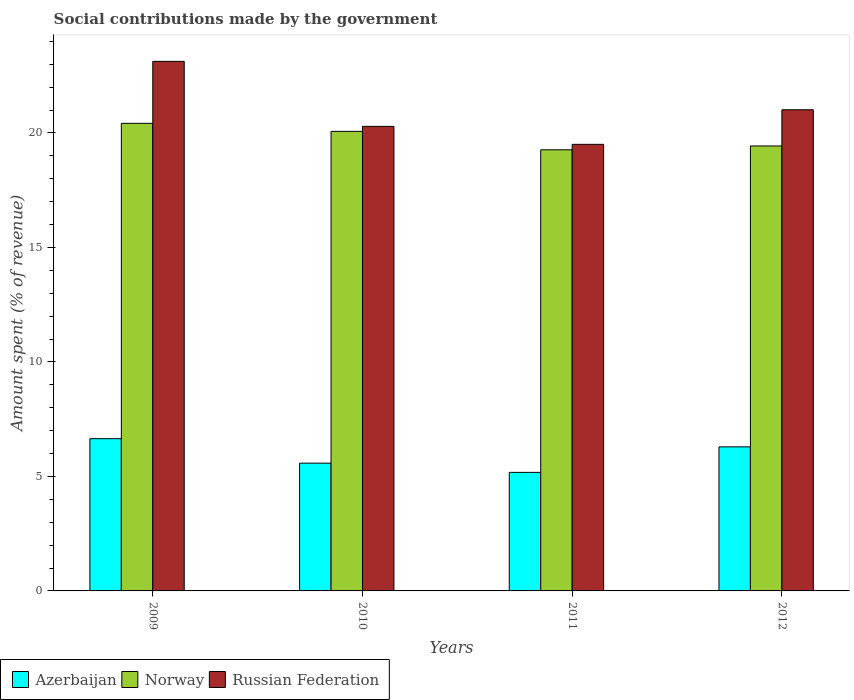How many different coloured bars are there?
Make the answer very short. 3. How many groups of bars are there?
Ensure brevity in your answer.  4. How many bars are there on the 2nd tick from the left?
Provide a succinct answer. 3. What is the label of the 1st group of bars from the left?
Offer a very short reply. 2009. What is the amount spent (in %) on social contributions in Russian Federation in 2012?
Your answer should be very brief. 21.01. Across all years, what is the maximum amount spent (in %) on social contributions in Norway?
Keep it short and to the point. 20.42. Across all years, what is the minimum amount spent (in %) on social contributions in Azerbaijan?
Provide a succinct answer. 5.18. In which year was the amount spent (in %) on social contributions in Azerbaijan maximum?
Ensure brevity in your answer.  2009. What is the total amount spent (in %) on social contributions in Azerbaijan in the graph?
Provide a short and direct response. 23.7. What is the difference between the amount spent (in %) on social contributions in Azerbaijan in 2010 and that in 2012?
Your answer should be very brief. -0.71. What is the difference between the amount spent (in %) on social contributions in Russian Federation in 2009 and the amount spent (in %) on social contributions in Norway in 2012?
Make the answer very short. 3.7. What is the average amount spent (in %) on social contributions in Norway per year?
Your response must be concise. 19.8. In the year 2009, what is the difference between the amount spent (in %) on social contributions in Azerbaijan and amount spent (in %) on social contributions in Norway?
Provide a succinct answer. -13.77. In how many years, is the amount spent (in %) on social contributions in Norway greater than 12 %?
Give a very brief answer. 4. What is the ratio of the amount spent (in %) on social contributions in Norway in 2010 to that in 2011?
Provide a succinct answer. 1.04. What is the difference between the highest and the second highest amount spent (in %) on social contributions in Azerbaijan?
Give a very brief answer. 0.36. What is the difference between the highest and the lowest amount spent (in %) on social contributions in Russian Federation?
Give a very brief answer. 3.62. What does the 3rd bar from the left in 2010 represents?
Your response must be concise. Russian Federation. How many bars are there?
Offer a terse response. 12. Are the values on the major ticks of Y-axis written in scientific E-notation?
Your response must be concise. No. Does the graph contain any zero values?
Ensure brevity in your answer.  No. How are the legend labels stacked?
Keep it short and to the point. Horizontal. What is the title of the graph?
Make the answer very short. Social contributions made by the government. What is the label or title of the Y-axis?
Provide a short and direct response. Amount spent (% of revenue). What is the Amount spent (% of revenue) in Azerbaijan in 2009?
Make the answer very short. 6.65. What is the Amount spent (% of revenue) in Norway in 2009?
Your answer should be compact. 20.42. What is the Amount spent (% of revenue) in Russian Federation in 2009?
Keep it short and to the point. 23.13. What is the Amount spent (% of revenue) of Azerbaijan in 2010?
Give a very brief answer. 5.58. What is the Amount spent (% of revenue) in Norway in 2010?
Your answer should be very brief. 20.07. What is the Amount spent (% of revenue) in Russian Federation in 2010?
Your response must be concise. 20.29. What is the Amount spent (% of revenue) in Azerbaijan in 2011?
Your response must be concise. 5.18. What is the Amount spent (% of revenue) in Norway in 2011?
Your response must be concise. 19.27. What is the Amount spent (% of revenue) of Russian Federation in 2011?
Provide a succinct answer. 19.5. What is the Amount spent (% of revenue) in Azerbaijan in 2012?
Offer a very short reply. 6.29. What is the Amount spent (% of revenue) of Norway in 2012?
Ensure brevity in your answer.  19.43. What is the Amount spent (% of revenue) of Russian Federation in 2012?
Your answer should be very brief. 21.01. Across all years, what is the maximum Amount spent (% of revenue) of Azerbaijan?
Provide a short and direct response. 6.65. Across all years, what is the maximum Amount spent (% of revenue) in Norway?
Keep it short and to the point. 20.42. Across all years, what is the maximum Amount spent (% of revenue) in Russian Federation?
Offer a very short reply. 23.13. Across all years, what is the minimum Amount spent (% of revenue) in Azerbaijan?
Your answer should be very brief. 5.18. Across all years, what is the minimum Amount spent (% of revenue) in Norway?
Keep it short and to the point. 19.27. Across all years, what is the minimum Amount spent (% of revenue) in Russian Federation?
Make the answer very short. 19.5. What is the total Amount spent (% of revenue) of Azerbaijan in the graph?
Offer a terse response. 23.7. What is the total Amount spent (% of revenue) in Norway in the graph?
Make the answer very short. 79.19. What is the total Amount spent (% of revenue) of Russian Federation in the graph?
Provide a short and direct response. 83.94. What is the difference between the Amount spent (% of revenue) of Azerbaijan in 2009 and that in 2010?
Your answer should be very brief. 1.07. What is the difference between the Amount spent (% of revenue) of Norway in 2009 and that in 2010?
Ensure brevity in your answer.  0.35. What is the difference between the Amount spent (% of revenue) of Russian Federation in 2009 and that in 2010?
Your response must be concise. 2.84. What is the difference between the Amount spent (% of revenue) in Azerbaijan in 2009 and that in 2011?
Your answer should be very brief. 1.47. What is the difference between the Amount spent (% of revenue) of Norway in 2009 and that in 2011?
Provide a succinct answer. 1.16. What is the difference between the Amount spent (% of revenue) in Russian Federation in 2009 and that in 2011?
Ensure brevity in your answer.  3.62. What is the difference between the Amount spent (% of revenue) in Azerbaijan in 2009 and that in 2012?
Provide a succinct answer. 0.36. What is the difference between the Amount spent (% of revenue) in Norway in 2009 and that in 2012?
Give a very brief answer. 0.99. What is the difference between the Amount spent (% of revenue) of Russian Federation in 2009 and that in 2012?
Offer a terse response. 2.11. What is the difference between the Amount spent (% of revenue) in Azerbaijan in 2010 and that in 2011?
Provide a short and direct response. 0.4. What is the difference between the Amount spent (% of revenue) of Norway in 2010 and that in 2011?
Your answer should be compact. 0.81. What is the difference between the Amount spent (% of revenue) of Russian Federation in 2010 and that in 2011?
Give a very brief answer. 0.78. What is the difference between the Amount spent (% of revenue) in Azerbaijan in 2010 and that in 2012?
Your response must be concise. -0.71. What is the difference between the Amount spent (% of revenue) of Norway in 2010 and that in 2012?
Keep it short and to the point. 0.64. What is the difference between the Amount spent (% of revenue) of Russian Federation in 2010 and that in 2012?
Your answer should be compact. -0.73. What is the difference between the Amount spent (% of revenue) in Azerbaijan in 2011 and that in 2012?
Provide a succinct answer. -1.11. What is the difference between the Amount spent (% of revenue) in Norway in 2011 and that in 2012?
Give a very brief answer. -0.17. What is the difference between the Amount spent (% of revenue) of Russian Federation in 2011 and that in 2012?
Make the answer very short. -1.51. What is the difference between the Amount spent (% of revenue) in Azerbaijan in 2009 and the Amount spent (% of revenue) in Norway in 2010?
Offer a terse response. -13.42. What is the difference between the Amount spent (% of revenue) of Azerbaijan in 2009 and the Amount spent (% of revenue) of Russian Federation in 2010?
Give a very brief answer. -13.64. What is the difference between the Amount spent (% of revenue) in Norway in 2009 and the Amount spent (% of revenue) in Russian Federation in 2010?
Your answer should be compact. 0.13. What is the difference between the Amount spent (% of revenue) of Azerbaijan in 2009 and the Amount spent (% of revenue) of Norway in 2011?
Your response must be concise. -12.62. What is the difference between the Amount spent (% of revenue) of Azerbaijan in 2009 and the Amount spent (% of revenue) of Russian Federation in 2011?
Your response must be concise. -12.86. What is the difference between the Amount spent (% of revenue) of Norway in 2009 and the Amount spent (% of revenue) of Russian Federation in 2011?
Ensure brevity in your answer.  0.92. What is the difference between the Amount spent (% of revenue) of Azerbaijan in 2009 and the Amount spent (% of revenue) of Norway in 2012?
Offer a terse response. -12.78. What is the difference between the Amount spent (% of revenue) in Azerbaijan in 2009 and the Amount spent (% of revenue) in Russian Federation in 2012?
Offer a terse response. -14.37. What is the difference between the Amount spent (% of revenue) in Norway in 2009 and the Amount spent (% of revenue) in Russian Federation in 2012?
Provide a succinct answer. -0.59. What is the difference between the Amount spent (% of revenue) in Azerbaijan in 2010 and the Amount spent (% of revenue) in Norway in 2011?
Offer a very short reply. -13.69. What is the difference between the Amount spent (% of revenue) in Azerbaijan in 2010 and the Amount spent (% of revenue) in Russian Federation in 2011?
Offer a terse response. -13.92. What is the difference between the Amount spent (% of revenue) in Norway in 2010 and the Amount spent (% of revenue) in Russian Federation in 2011?
Your response must be concise. 0.57. What is the difference between the Amount spent (% of revenue) in Azerbaijan in 2010 and the Amount spent (% of revenue) in Norway in 2012?
Provide a succinct answer. -13.85. What is the difference between the Amount spent (% of revenue) in Azerbaijan in 2010 and the Amount spent (% of revenue) in Russian Federation in 2012?
Provide a succinct answer. -15.43. What is the difference between the Amount spent (% of revenue) in Norway in 2010 and the Amount spent (% of revenue) in Russian Federation in 2012?
Provide a succinct answer. -0.94. What is the difference between the Amount spent (% of revenue) of Azerbaijan in 2011 and the Amount spent (% of revenue) of Norway in 2012?
Offer a terse response. -14.25. What is the difference between the Amount spent (% of revenue) of Azerbaijan in 2011 and the Amount spent (% of revenue) of Russian Federation in 2012?
Offer a very short reply. -15.84. What is the difference between the Amount spent (% of revenue) of Norway in 2011 and the Amount spent (% of revenue) of Russian Federation in 2012?
Your response must be concise. -1.75. What is the average Amount spent (% of revenue) in Azerbaijan per year?
Offer a terse response. 5.92. What is the average Amount spent (% of revenue) of Norway per year?
Your answer should be very brief. 19.8. What is the average Amount spent (% of revenue) of Russian Federation per year?
Give a very brief answer. 20.98. In the year 2009, what is the difference between the Amount spent (% of revenue) of Azerbaijan and Amount spent (% of revenue) of Norway?
Ensure brevity in your answer.  -13.77. In the year 2009, what is the difference between the Amount spent (% of revenue) in Azerbaijan and Amount spent (% of revenue) in Russian Federation?
Your answer should be compact. -16.48. In the year 2009, what is the difference between the Amount spent (% of revenue) of Norway and Amount spent (% of revenue) of Russian Federation?
Offer a terse response. -2.71. In the year 2010, what is the difference between the Amount spent (% of revenue) of Azerbaijan and Amount spent (% of revenue) of Norway?
Your response must be concise. -14.49. In the year 2010, what is the difference between the Amount spent (% of revenue) of Azerbaijan and Amount spent (% of revenue) of Russian Federation?
Your response must be concise. -14.71. In the year 2010, what is the difference between the Amount spent (% of revenue) in Norway and Amount spent (% of revenue) in Russian Federation?
Provide a succinct answer. -0.22. In the year 2011, what is the difference between the Amount spent (% of revenue) in Azerbaijan and Amount spent (% of revenue) in Norway?
Offer a terse response. -14.09. In the year 2011, what is the difference between the Amount spent (% of revenue) of Azerbaijan and Amount spent (% of revenue) of Russian Federation?
Your answer should be compact. -14.33. In the year 2011, what is the difference between the Amount spent (% of revenue) of Norway and Amount spent (% of revenue) of Russian Federation?
Keep it short and to the point. -0.24. In the year 2012, what is the difference between the Amount spent (% of revenue) in Azerbaijan and Amount spent (% of revenue) in Norway?
Provide a succinct answer. -13.14. In the year 2012, what is the difference between the Amount spent (% of revenue) of Azerbaijan and Amount spent (% of revenue) of Russian Federation?
Your answer should be compact. -14.72. In the year 2012, what is the difference between the Amount spent (% of revenue) in Norway and Amount spent (% of revenue) in Russian Federation?
Provide a succinct answer. -1.58. What is the ratio of the Amount spent (% of revenue) in Azerbaijan in 2009 to that in 2010?
Your answer should be compact. 1.19. What is the ratio of the Amount spent (% of revenue) of Norway in 2009 to that in 2010?
Offer a terse response. 1.02. What is the ratio of the Amount spent (% of revenue) of Russian Federation in 2009 to that in 2010?
Offer a terse response. 1.14. What is the ratio of the Amount spent (% of revenue) of Azerbaijan in 2009 to that in 2011?
Give a very brief answer. 1.28. What is the ratio of the Amount spent (% of revenue) of Norway in 2009 to that in 2011?
Provide a short and direct response. 1.06. What is the ratio of the Amount spent (% of revenue) in Russian Federation in 2009 to that in 2011?
Offer a very short reply. 1.19. What is the ratio of the Amount spent (% of revenue) in Azerbaijan in 2009 to that in 2012?
Offer a very short reply. 1.06. What is the ratio of the Amount spent (% of revenue) of Norway in 2009 to that in 2012?
Your answer should be very brief. 1.05. What is the ratio of the Amount spent (% of revenue) in Russian Federation in 2009 to that in 2012?
Make the answer very short. 1.1. What is the ratio of the Amount spent (% of revenue) in Azerbaijan in 2010 to that in 2011?
Offer a terse response. 1.08. What is the ratio of the Amount spent (% of revenue) in Norway in 2010 to that in 2011?
Keep it short and to the point. 1.04. What is the ratio of the Amount spent (% of revenue) in Russian Federation in 2010 to that in 2011?
Offer a very short reply. 1.04. What is the ratio of the Amount spent (% of revenue) in Azerbaijan in 2010 to that in 2012?
Ensure brevity in your answer.  0.89. What is the ratio of the Amount spent (% of revenue) of Norway in 2010 to that in 2012?
Provide a succinct answer. 1.03. What is the ratio of the Amount spent (% of revenue) of Russian Federation in 2010 to that in 2012?
Ensure brevity in your answer.  0.97. What is the ratio of the Amount spent (% of revenue) of Azerbaijan in 2011 to that in 2012?
Ensure brevity in your answer.  0.82. What is the ratio of the Amount spent (% of revenue) of Norway in 2011 to that in 2012?
Offer a terse response. 0.99. What is the ratio of the Amount spent (% of revenue) in Russian Federation in 2011 to that in 2012?
Your answer should be very brief. 0.93. What is the difference between the highest and the second highest Amount spent (% of revenue) in Azerbaijan?
Your response must be concise. 0.36. What is the difference between the highest and the second highest Amount spent (% of revenue) of Norway?
Offer a very short reply. 0.35. What is the difference between the highest and the second highest Amount spent (% of revenue) of Russian Federation?
Keep it short and to the point. 2.11. What is the difference between the highest and the lowest Amount spent (% of revenue) of Azerbaijan?
Keep it short and to the point. 1.47. What is the difference between the highest and the lowest Amount spent (% of revenue) of Norway?
Provide a short and direct response. 1.16. What is the difference between the highest and the lowest Amount spent (% of revenue) of Russian Federation?
Offer a very short reply. 3.62. 